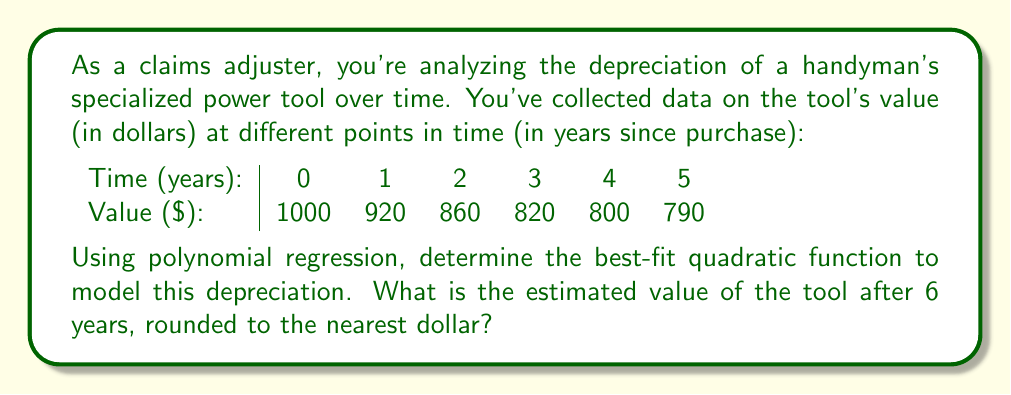Show me your answer to this math problem. To solve this problem, we'll use quadratic regression to find the best-fit polynomial of degree 2. The general form of a quadratic function is:

$$f(x) = ax^2 + bx + c$$

Where $x$ represents the time in years, and $f(x)$ represents the value in dollars.

1. First, we need to set up the system of normal equations for quadratic regression:

   $$\begin{cases}
   \sum y = an + b\sum x + c\sum x^2 \\
   \sum xy = a\sum x + b\sum x^2 + c\sum x^3 \\
   \sum x^2y = a\sum x^2 + b\sum x^3 + c\sum x^4
   \end{cases}$$

2. Calculate the required sums:
   
   $n = 6$
   $\sum x = 0 + 1 + 2 + 3 + 4 + 5 = 15$
   $\sum x^2 = 0 + 1 + 4 + 9 + 16 + 25 = 55$
   $\sum x^3 = 0 + 1 + 8 + 27 + 64 + 125 = 225$
   $\sum x^4 = 0 + 1 + 16 + 81 + 256 + 625 = 979$
   $\sum y = 1000 + 920 + 860 + 820 + 800 + 790 = 5190$
   $\sum xy = 0 + 920 + 1720 + 2460 + 3200 + 3950 = 12250$
   $\sum x^2y = 0 + 920 + 3440 + 7380 + 12800 + 19750 = 44290$

3. Substitute these values into the system of equations:

   $$\begin{cases}
   5190 = 6a + 15b + 55c \\
   12250 = 15a + 55b + 225c \\
   44290 = 55a + 225b + 979c
   \end{cases}$$

4. Solve this system of equations (using a calculator or computer algebra system) to get:

   $a \approx 8.9286$
   $b \approx -93.2143$
   $c \approx 996.4286$

5. Therefore, the quadratic function that best fits the data is:

   $$f(x) \approx 8.9286x^2 - 93.2143x + 996.4286$$

6. To estimate the value after 6 years, substitute $x = 6$ into this function:

   $$f(6) \approx 8.9286(6)^2 - 93.2143(6) + 996.4286$$
   $$f(6) \approx 321.4296 - 559.2858 + 996.4286$$
   $$f(6) \approx 758.5724$$

7. Rounding to the nearest dollar, we get $759.
Answer: $759 